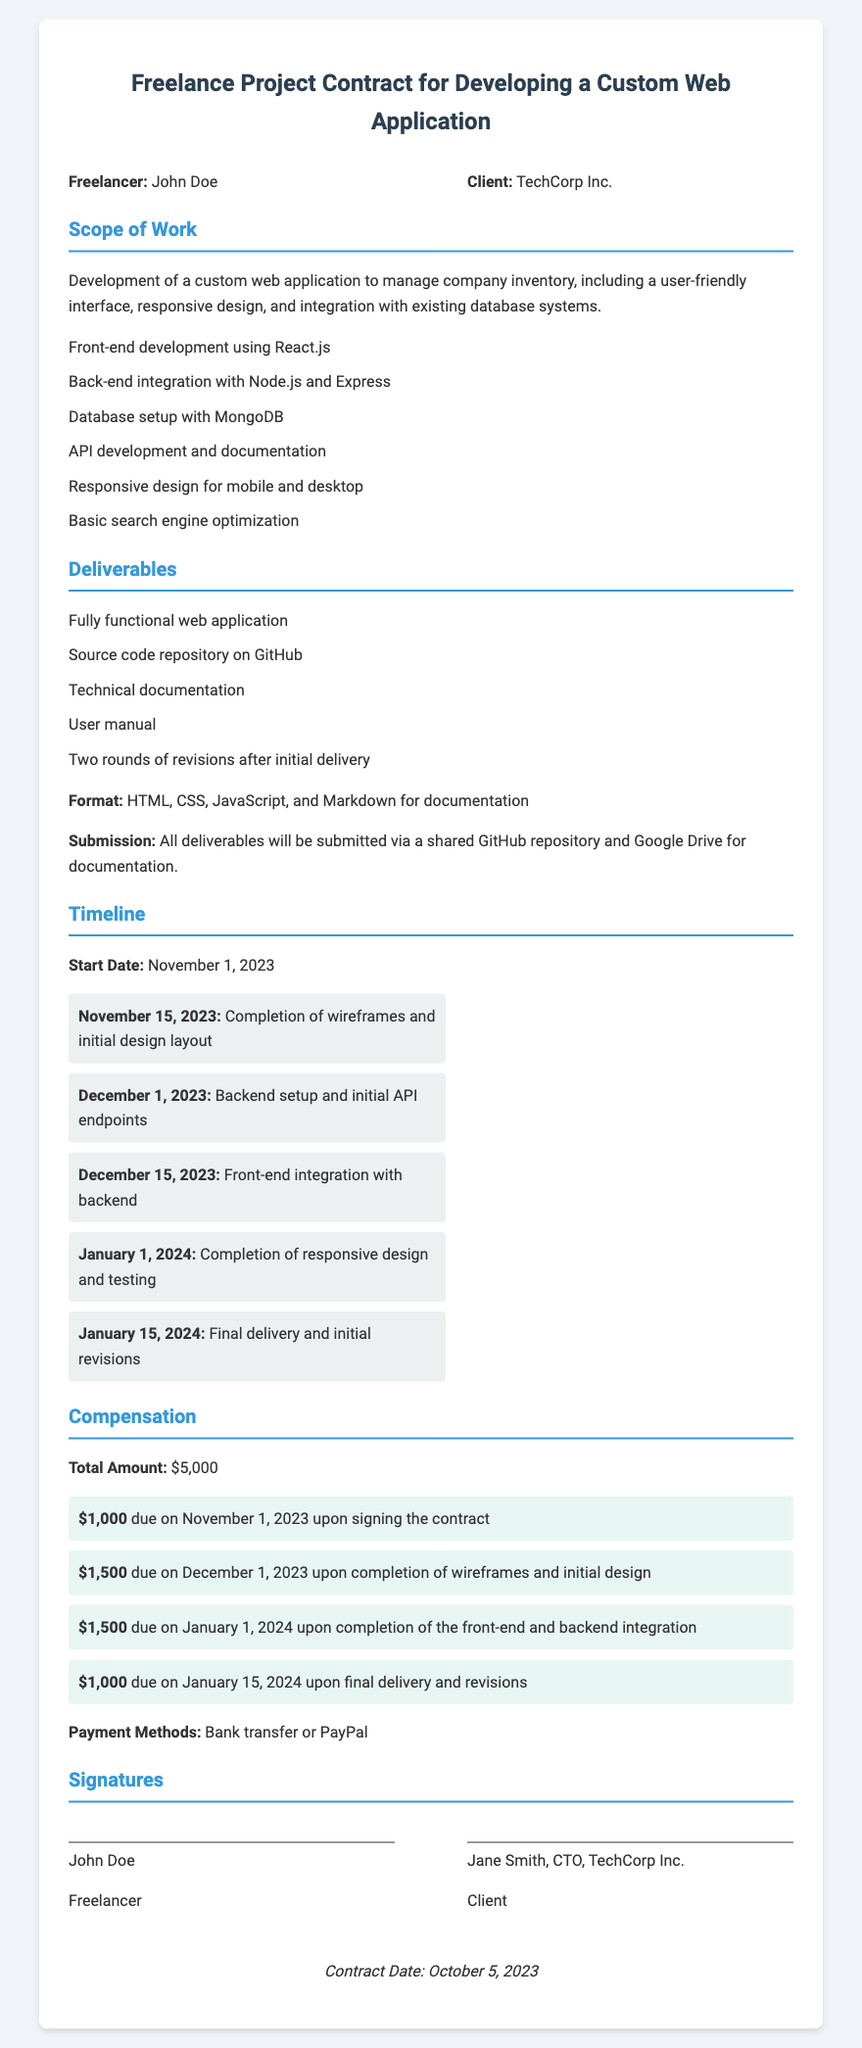what is the name of the freelancer? The name of the freelancer is listed in the parties section of the document.
Answer: John Doe who is the client? The client is mentioned alongside the freelancer in the parties section of the document.
Answer: TechCorp Inc what is the total amount of compensation? The total amount is specified in the compensation section of the document.
Answer: $5,000 when does the contract start? The start date is mentioned in the timeline section of the document.
Answer: November 1, 2023 how many rounds of revisions are included? The number of revisions is specified in the deliverables section of the document.
Answer: Two rounds what is the final payment amount? The final payment amount is detailed in the compensation section of the document.
Answer: $1,000 what is the payment method? The payment methods are listed in the compensation section of the document.
Answer: Bank transfer or PayPal what is the due date for the first payment? The due date for the first payment is mentioned in the compensation section of the document.
Answer: November 1, 2023 who signed the contract on behalf of the client? The signature section of the document identifies the client’s representative.
Answer: Jane Smith, CTO, TechCorp Inc 